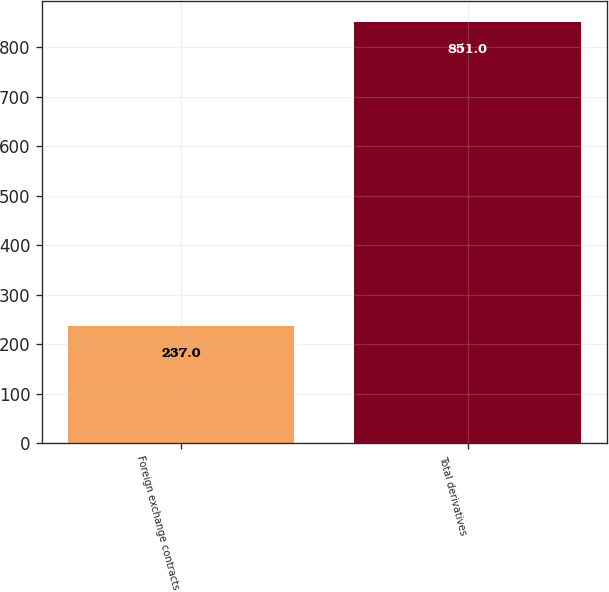Convert chart. <chart><loc_0><loc_0><loc_500><loc_500><bar_chart><fcel>Foreign exchange contracts<fcel>Total derivatives<nl><fcel>237<fcel>851<nl></chart> 